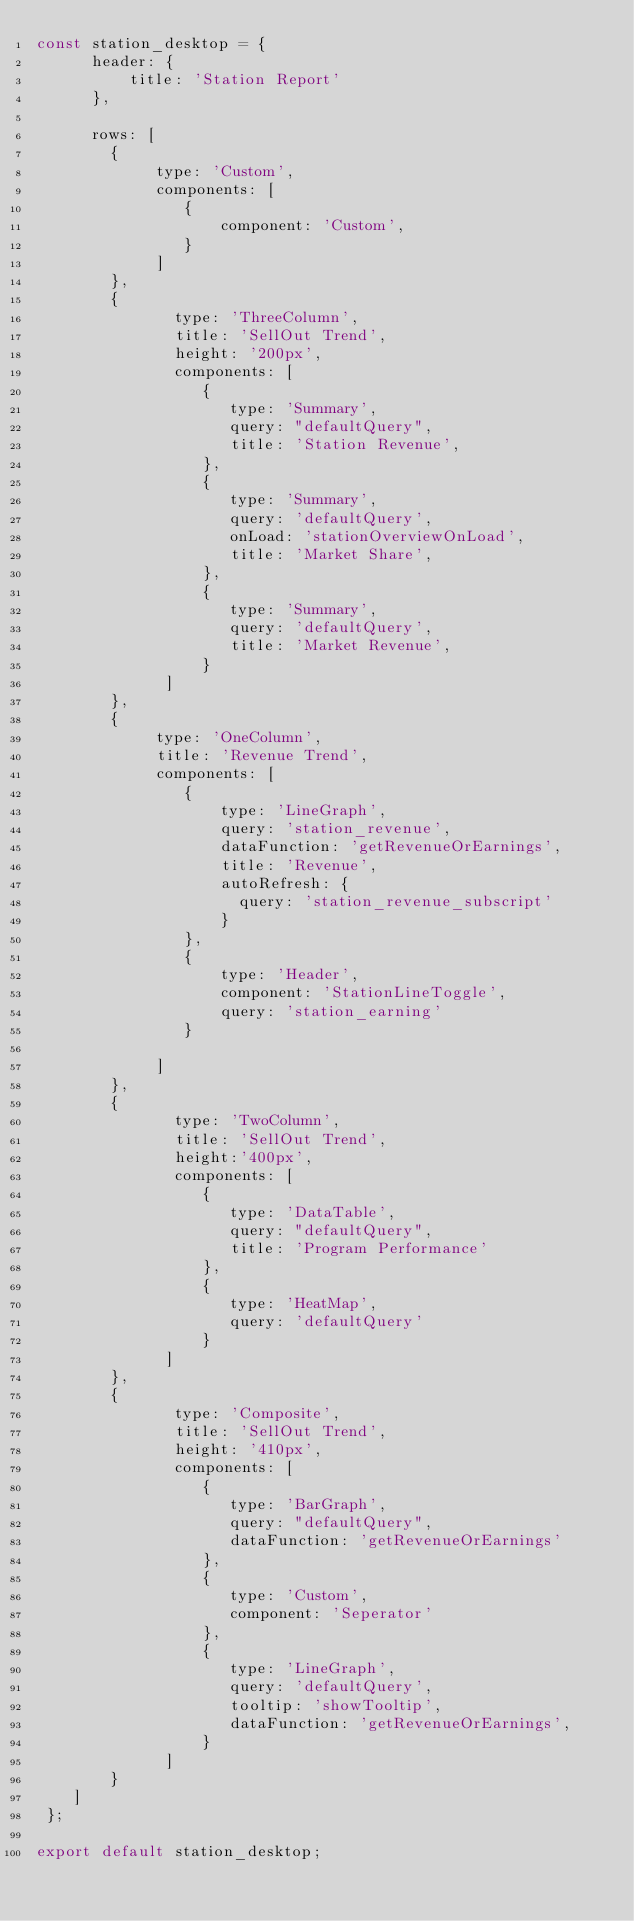Convert code to text. <code><loc_0><loc_0><loc_500><loc_500><_JavaScript_>const station_desktop = {
      header: {
          title: 'Station Report'
      },

      rows: [
        {
             type: 'Custom',
             components: [
                {
                    component: 'Custom',
                }
             ]
        },
        {
               type: 'ThreeColumn',
               title: 'SellOut Trend',
               height: '200px',
               components: [
                  {
                     type: 'Summary',
                     query: "defaultQuery",
                     title: 'Station Revenue',
                  },
                  {
                     type: 'Summary',
                     query: 'defaultQuery',
                     onLoad: 'stationOverviewOnLoad',
                     title: 'Market Share',
                  },
                  {
                     type: 'Summary',
                     query: 'defaultQuery',
                     title: 'Market Revenue',
                  }
              ]
        },
        {
             type: 'OneColumn',
             title: 'Revenue Trend',
             components: [
                {
                    type: 'LineGraph',
                    query: 'station_revenue',
                    dataFunction: 'getRevenueOrEarnings',
                    title: 'Revenue',
                    autoRefresh: {
                      query: 'station_revenue_subscript'
                    }
                },
                {
                    type: 'Header',
                    component: 'StationLineToggle',
                    query: 'station_earning'
                }

             ]
        },
        {
               type: 'TwoColumn',
               title: 'SellOut Trend',
               height:'400px',
               components: [
                  {
                     type: 'DataTable',
                     query: "defaultQuery",
                     title: 'Program Performance'
                  },
                  {
                     type: 'HeatMap',
                     query: 'defaultQuery'
                  }
              ]
        },
        {
               type: 'Composite',
               title: 'SellOut Trend',
               height: '410px',
               components: [
                  {
                     type: 'BarGraph',
                     query: "defaultQuery",
                     dataFunction: 'getRevenueOrEarnings'
                  },
                  {
                     type: 'Custom',
                     component: 'Seperator'
                  },
                  {
                     type: 'LineGraph',
                     query: 'defaultQuery',
                     tooltip: 'showTooltip',
                     dataFunction: 'getRevenueOrEarnings',
                  }
              ]
        }
    ]
 };

export default station_desktop;
</code> 